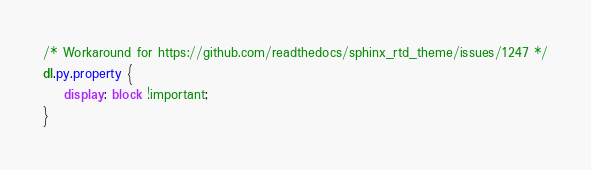Convert code to text. <code><loc_0><loc_0><loc_500><loc_500><_CSS_>/* Workaround for https://github.com/readthedocs/sphinx_rtd_theme/issues/1247 */
dl.py.property {
    display: block !important;
}
</code> 